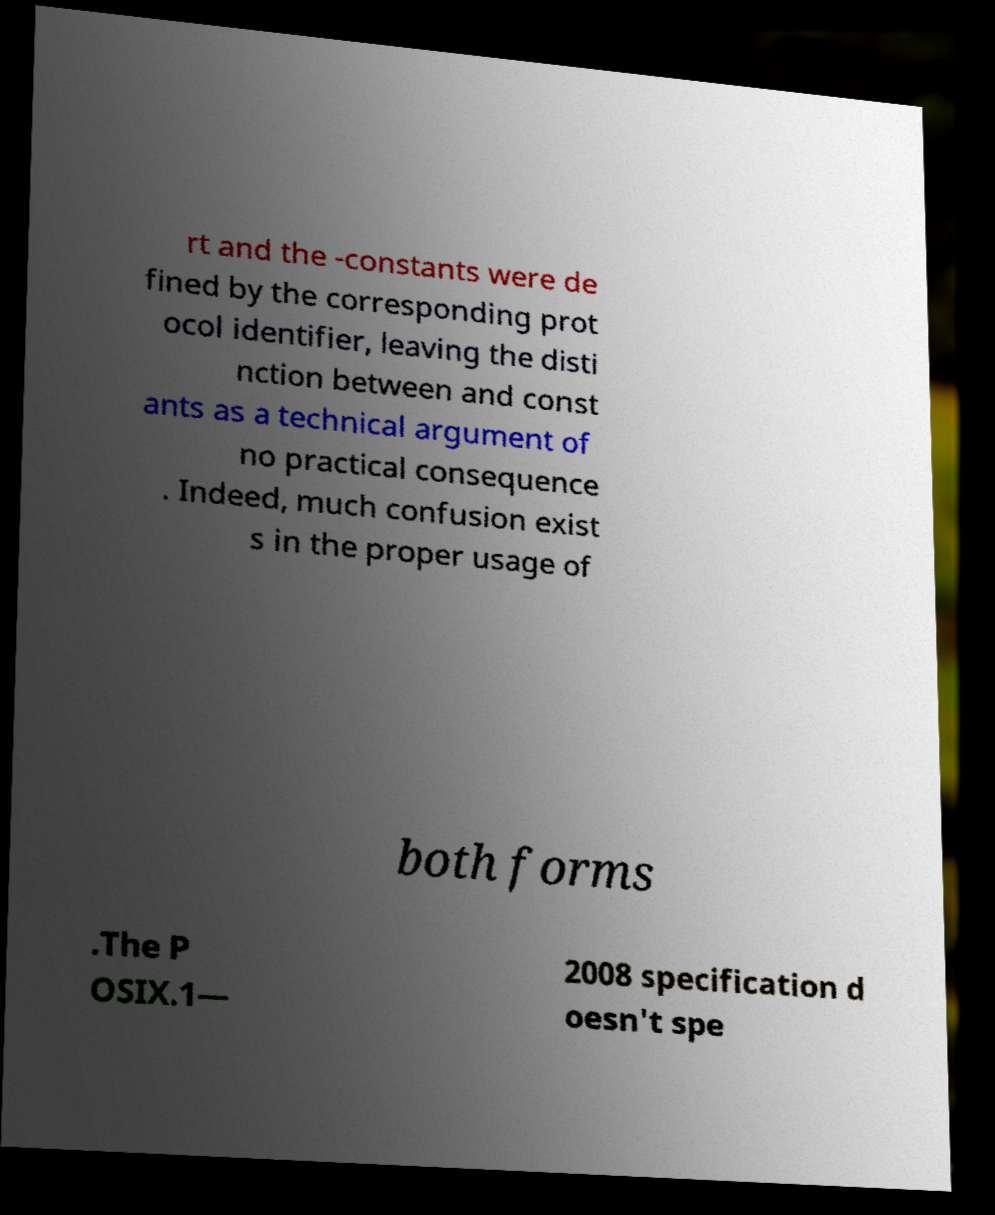What messages or text are displayed in this image? I need them in a readable, typed format. rt and the -constants were de fined by the corresponding prot ocol identifier, leaving the disti nction between and const ants as a technical argument of no practical consequence . Indeed, much confusion exist s in the proper usage of both forms .The P OSIX.1— 2008 specification d oesn't spe 